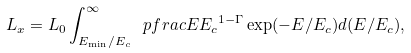Convert formula to latex. <formula><loc_0><loc_0><loc_500><loc_500>L _ { x } = L _ { 0 } \int _ { E _ { \min } / E _ { c } } ^ { \infty } \ p f r a c { E } { E _ { c } } ^ { 1 - \Gamma } \exp ( - E / E _ { c } ) d ( E / E _ { c } ) ,</formula> 